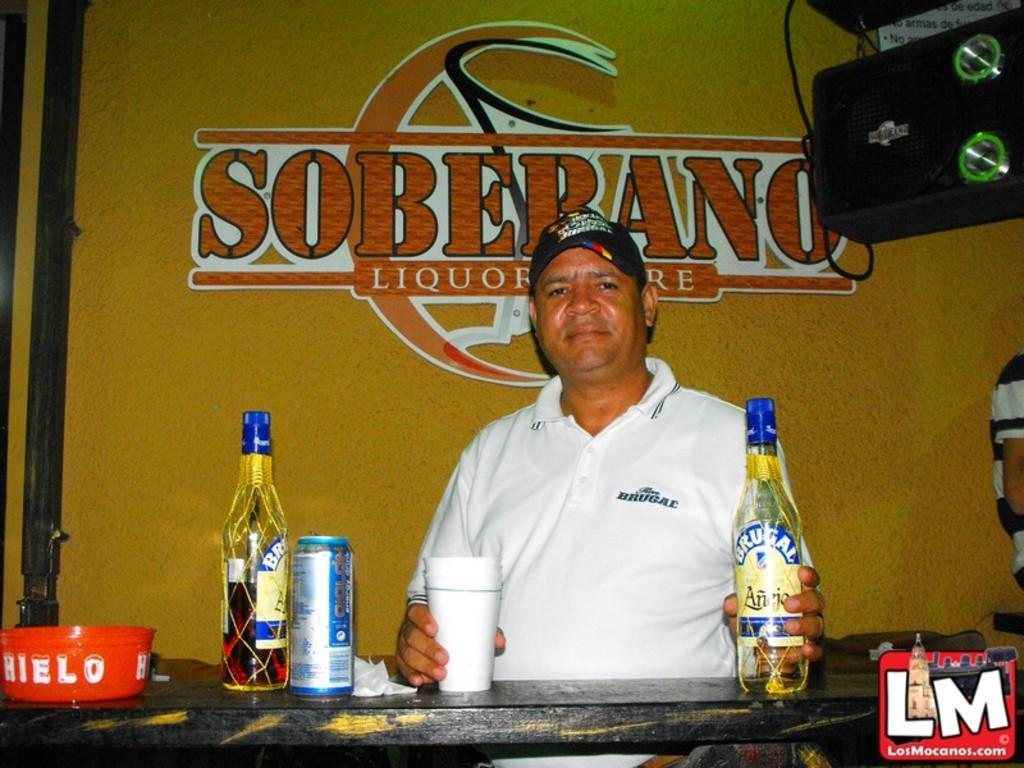<image>
Share a concise interpretation of the image provided. A man in a white shirt is seated before a Soberano alcohol advertisement. 